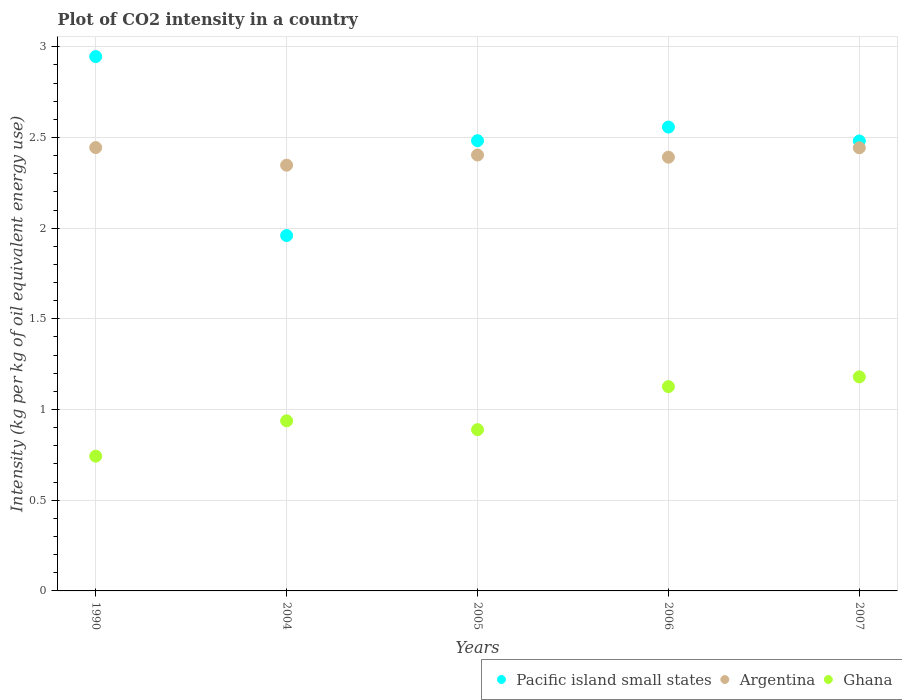How many different coloured dotlines are there?
Provide a short and direct response. 3. Is the number of dotlines equal to the number of legend labels?
Your response must be concise. Yes. What is the CO2 intensity in in Ghana in 2006?
Offer a very short reply. 1.13. Across all years, what is the maximum CO2 intensity in in Pacific island small states?
Provide a short and direct response. 2.95. Across all years, what is the minimum CO2 intensity in in Pacific island small states?
Give a very brief answer. 1.96. In which year was the CO2 intensity in in Ghana maximum?
Offer a very short reply. 2007. What is the total CO2 intensity in in Pacific island small states in the graph?
Ensure brevity in your answer.  12.43. What is the difference between the CO2 intensity in in Pacific island small states in 1990 and that in 2004?
Make the answer very short. 0.99. What is the difference between the CO2 intensity in in Ghana in 2006 and the CO2 intensity in in Pacific island small states in 2007?
Offer a very short reply. -1.35. What is the average CO2 intensity in in Ghana per year?
Make the answer very short. 0.98. In the year 2004, what is the difference between the CO2 intensity in in Pacific island small states and CO2 intensity in in Argentina?
Offer a very short reply. -0.39. In how many years, is the CO2 intensity in in Argentina greater than 1.3 kg?
Make the answer very short. 5. What is the ratio of the CO2 intensity in in Ghana in 1990 to that in 2005?
Make the answer very short. 0.84. What is the difference between the highest and the second highest CO2 intensity in in Argentina?
Keep it short and to the point. 0. What is the difference between the highest and the lowest CO2 intensity in in Argentina?
Keep it short and to the point. 0.1. In how many years, is the CO2 intensity in in Argentina greater than the average CO2 intensity in in Argentina taken over all years?
Keep it short and to the point. 2. Is the sum of the CO2 intensity in in Argentina in 1990 and 2004 greater than the maximum CO2 intensity in in Pacific island small states across all years?
Keep it short and to the point. Yes. Is the CO2 intensity in in Argentina strictly greater than the CO2 intensity in in Pacific island small states over the years?
Your response must be concise. No. Is the CO2 intensity in in Argentina strictly less than the CO2 intensity in in Pacific island small states over the years?
Offer a very short reply. No. How many years are there in the graph?
Offer a terse response. 5. What is the difference between two consecutive major ticks on the Y-axis?
Provide a short and direct response. 0.5. Does the graph contain any zero values?
Provide a succinct answer. No. Does the graph contain grids?
Offer a terse response. Yes. How are the legend labels stacked?
Provide a short and direct response. Horizontal. What is the title of the graph?
Provide a succinct answer. Plot of CO2 intensity in a country. Does "Mali" appear as one of the legend labels in the graph?
Your answer should be very brief. No. What is the label or title of the Y-axis?
Ensure brevity in your answer.  Intensity (kg per kg of oil equivalent energy use). What is the Intensity (kg per kg of oil equivalent energy use) in Pacific island small states in 1990?
Your response must be concise. 2.95. What is the Intensity (kg per kg of oil equivalent energy use) of Argentina in 1990?
Your response must be concise. 2.44. What is the Intensity (kg per kg of oil equivalent energy use) in Ghana in 1990?
Keep it short and to the point. 0.74. What is the Intensity (kg per kg of oil equivalent energy use) in Pacific island small states in 2004?
Offer a terse response. 1.96. What is the Intensity (kg per kg of oil equivalent energy use) in Argentina in 2004?
Make the answer very short. 2.35. What is the Intensity (kg per kg of oil equivalent energy use) in Ghana in 2004?
Offer a terse response. 0.94. What is the Intensity (kg per kg of oil equivalent energy use) in Pacific island small states in 2005?
Provide a short and direct response. 2.48. What is the Intensity (kg per kg of oil equivalent energy use) in Argentina in 2005?
Provide a short and direct response. 2.4. What is the Intensity (kg per kg of oil equivalent energy use) of Ghana in 2005?
Offer a very short reply. 0.89. What is the Intensity (kg per kg of oil equivalent energy use) of Pacific island small states in 2006?
Offer a terse response. 2.56. What is the Intensity (kg per kg of oil equivalent energy use) in Argentina in 2006?
Give a very brief answer. 2.39. What is the Intensity (kg per kg of oil equivalent energy use) in Ghana in 2006?
Your response must be concise. 1.13. What is the Intensity (kg per kg of oil equivalent energy use) of Pacific island small states in 2007?
Your answer should be very brief. 2.48. What is the Intensity (kg per kg of oil equivalent energy use) in Argentina in 2007?
Ensure brevity in your answer.  2.44. What is the Intensity (kg per kg of oil equivalent energy use) in Ghana in 2007?
Keep it short and to the point. 1.18. Across all years, what is the maximum Intensity (kg per kg of oil equivalent energy use) in Pacific island small states?
Give a very brief answer. 2.95. Across all years, what is the maximum Intensity (kg per kg of oil equivalent energy use) of Argentina?
Make the answer very short. 2.44. Across all years, what is the maximum Intensity (kg per kg of oil equivalent energy use) in Ghana?
Give a very brief answer. 1.18. Across all years, what is the minimum Intensity (kg per kg of oil equivalent energy use) of Pacific island small states?
Your answer should be compact. 1.96. Across all years, what is the minimum Intensity (kg per kg of oil equivalent energy use) of Argentina?
Ensure brevity in your answer.  2.35. Across all years, what is the minimum Intensity (kg per kg of oil equivalent energy use) of Ghana?
Your answer should be very brief. 0.74. What is the total Intensity (kg per kg of oil equivalent energy use) of Pacific island small states in the graph?
Your response must be concise. 12.43. What is the total Intensity (kg per kg of oil equivalent energy use) in Argentina in the graph?
Offer a very short reply. 12.03. What is the total Intensity (kg per kg of oil equivalent energy use) in Ghana in the graph?
Offer a very short reply. 4.88. What is the difference between the Intensity (kg per kg of oil equivalent energy use) of Pacific island small states in 1990 and that in 2004?
Offer a terse response. 0.99. What is the difference between the Intensity (kg per kg of oil equivalent energy use) in Argentina in 1990 and that in 2004?
Your answer should be very brief. 0.1. What is the difference between the Intensity (kg per kg of oil equivalent energy use) in Ghana in 1990 and that in 2004?
Ensure brevity in your answer.  -0.19. What is the difference between the Intensity (kg per kg of oil equivalent energy use) of Pacific island small states in 1990 and that in 2005?
Offer a very short reply. 0.46. What is the difference between the Intensity (kg per kg of oil equivalent energy use) of Argentina in 1990 and that in 2005?
Keep it short and to the point. 0.04. What is the difference between the Intensity (kg per kg of oil equivalent energy use) of Ghana in 1990 and that in 2005?
Your response must be concise. -0.15. What is the difference between the Intensity (kg per kg of oil equivalent energy use) of Pacific island small states in 1990 and that in 2006?
Offer a terse response. 0.39. What is the difference between the Intensity (kg per kg of oil equivalent energy use) in Argentina in 1990 and that in 2006?
Offer a very short reply. 0.05. What is the difference between the Intensity (kg per kg of oil equivalent energy use) of Ghana in 1990 and that in 2006?
Your answer should be very brief. -0.38. What is the difference between the Intensity (kg per kg of oil equivalent energy use) of Pacific island small states in 1990 and that in 2007?
Your response must be concise. 0.47. What is the difference between the Intensity (kg per kg of oil equivalent energy use) in Argentina in 1990 and that in 2007?
Provide a succinct answer. 0. What is the difference between the Intensity (kg per kg of oil equivalent energy use) in Ghana in 1990 and that in 2007?
Offer a very short reply. -0.44. What is the difference between the Intensity (kg per kg of oil equivalent energy use) in Pacific island small states in 2004 and that in 2005?
Make the answer very short. -0.52. What is the difference between the Intensity (kg per kg of oil equivalent energy use) of Argentina in 2004 and that in 2005?
Your response must be concise. -0.06. What is the difference between the Intensity (kg per kg of oil equivalent energy use) in Ghana in 2004 and that in 2005?
Offer a terse response. 0.05. What is the difference between the Intensity (kg per kg of oil equivalent energy use) of Pacific island small states in 2004 and that in 2006?
Your response must be concise. -0.6. What is the difference between the Intensity (kg per kg of oil equivalent energy use) of Argentina in 2004 and that in 2006?
Offer a terse response. -0.04. What is the difference between the Intensity (kg per kg of oil equivalent energy use) of Ghana in 2004 and that in 2006?
Keep it short and to the point. -0.19. What is the difference between the Intensity (kg per kg of oil equivalent energy use) in Pacific island small states in 2004 and that in 2007?
Make the answer very short. -0.52. What is the difference between the Intensity (kg per kg of oil equivalent energy use) in Argentina in 2004 and that in 2007?
Give a very brief answer. -0.1. What is the difference between the Intensity (kg per kg of oil equivalent energy use) in Ghana in 2004 and that in 2007?
Your response must be concise. -0.24. What is the difference between the Intensity (kg per kg of oil equivalent energy use) in Pacific island small states in 2005 and that in 2006?
Offer a very short reply. -0.08. What is the difference between the Intensity (kg per kg of oil equivalent energy use) in Argentina in 2005 and that in 2006?
Provide a succinct answer. 0.01. What is the difference between the Intensity (kg per kg of oil equivalent energy use) in Ghana in 2005 and that in 2006?
Provide a succinct answer. -0.24. What is the difference between the Intensity (kg per kg of oil equivalent energy use) of Pacific island small states in 2005 and that in 2007?
Your answer should be compact. 0. What is the difference between the Intensity (kg per kg of oil equivalent energy use) in Argentina in 2005 and that in 2007?
Offer a terse response. -0.04. What is the difference between the Intensity (kg per kg of oil equivalent energy use) in Ghana in 2005 and that in 2007?
Keep it short and to the point. -0.29. What is the difference between the Intensity (kg per kg of oil equivalent energy use) in Pacific island small states in 2006 and that in 2007?
Your answer should be very brief. 0.08. What is the difference between the Intensity (kg per kg of oil equivalent energy use) in Argentina in 2006 and that in 2007?
Your answer should be very brief. -0.05. What is the difference between the Intensity (kg per kg of oil equivalent energy use) in Ghana in 2006 and that in 2007?
Ensure brevity in your answer.  -0.05. What is the difference between the Intensity (kg per kg of oil equivalent energy use) in Pacific island small states in 1990 and the Intensity (kg per kg of oil equivalent energy use) in Argentina in 2004?
Provide a short and direct response. 0.6. What is the difference between the Intensity (kg per kg of oil equivalent energy use) in Pacific island small states in 1990 and the Intensity (kg per kg of oil equivalent energy use) in Ghana in 2004?
Your response must be concise. 2.01. What is the difference between the Intensity (kg per kg of oil equivalent energy use) of Argentina in 1990 and the Intensity (kg per kg of oil equivalent energy use) of Ghana in 2004?
Give a very brief answer. 1.51. What is the difference between the Intensity (kg per kg of oil equivalent energy use) in Pacific island small states in 1990 and the Intensity (kg per kg of oil equivalent energy use) in Argentina in 2005?
Give a very brief answer. 0.54. What is the difference between the Intensity (kg per kg of oil equivalent energy use) of Pacific island small states in 1990 and the Intensity (kg per kg of oil equivalent energy use) of Ghana in 2005?
Offer a terse response. 2.06. What is the difference between the Intensity (kg per kg of oil equivalent energy use) of Argentina in 1990 and the Intensity (kg per kg of oil equivalent energy use) of Ghana in 2005?
Your answer should be compact. 1.56. What is the difference between the Intensity (kg per kg of oil equivalent energy use) of Pacific island small states in 1990 and the Intensity (kg per kg of oil equivalent energy use) of Argentina in 2006?
Offer a very short reply. 0.55. What is the difference between the Intensity (kg per kg of oil equivalent energy use) of Pacific island small states in 1990 and the Intensity (kg per kg of oil equivalent energy use) of Ghana in 2006?
Keep it short and to the point. 1.82. What is the difference between the Intensity (kg per kg of oil equivalent energy use) in Argentina in 1990 and the Intensity (kg per kg of oil equivalent energy use) in Ghana in 2006?
Ensure brevity in your answer.  1.32. What is the difference between the Intensity (kg per kg of oil equivalent energy use) in Pacific island small states in 1990 and the Intensity (kg per kg of oil equivalent energy use) in Argentina in 2007?
Offer a terse response. 0.5. What is the difference between the Intensity (kg per kg of oil equivalent energy use) in Pacific island small states in 1990 and the Intensity (kg per kg of oil equivalent energy use) in Ghana in 2007?
Offer a terse response. 1.77. What is the difference between the Intensity (kg per kg of oil equivalent energy use) of Argentina in 1990 and the Intensity (kg per kg of oil equivalent energy use) of Ghana in 2007?
Offer a very short reply. 1.26. What is the difference between the Intensity (kg per kg of oil equivalent energy use) of Pacific island small states in 2004 and the Intensity (kg per kg of oil equivalent energy use) of Argentina in 2005?
Your response must be concise. -0.44. What is the difference between the Intensity (kg per kg of oil equivalent energy use) of Pacific island small states in 2004 and the Intensity (kg per kg of oil equivalent energy use) of Ghana in 2005?
Your answer should be very brief. 1.07. What is the difference between the Intensity (kg per kg of oil equivalent energy use) of Argentina in 2004 and the Intensity (kg per kg of oil equivalent energy use) of Ghana in 2005?
Your response must be concise. 1.46. What is the difference between the Intensity (kg per kg of oil equivalent energy use) in Pacific island small states in 2004 and the Intensity (kg per kg of oil equivalent energy use) in Argentina in 2006?
Keep it short and to the point. -0.43. What is the difference between the Intensity (kg per kg of oil equivalent energy use) of Pacific island small states in 2004 and the Intensity (kg per kg of oil equivalent energy use) of Ghana in 2006?
Your answer should be very brief. 0.83. What is the difference between the Intensity (kg per kg of oil equivalent energy use) in Argentina in 2004 and the Intensity (kg per kg of oil equivalent energy use) in Ghana in 2006?
Offer a very short reply. 1.22. What is the difference between the Intensity (kg per kg of oil equivalent energy use) in Pacific island small states in 2004 and the Intensity (kg per kg of oil equivalent energy use) in Argentina in 2007?
Keep it short and to the point. -0.48. What is the difference between the Intensity (kg per kg of oil equivalent energy use) of Pacific island small states in 2004 and the Intensity (kg per kg of oil equivalent energy use) of Ghana in 2007?
Give a very brief answer. 0.78. What is the difference between the Intensity (kg per kg of oil equivalent energy use) in Argentina in 2004 and the Intensity (kg per kg of oil equivalent energy use) in Ghana in 2007?
Offer a terse response. 1.17. What is the difference between the Intensity (kg per kg of oil equivalent energy use) in Pacific island small states in 2005 and the Intensity (kg per kg of oil equivalent energy use) in Argentina in 2006?
Keep it short and to the point. 0.09. What is the difference between the Intensity (kg per kg of oil equivalent energy use) of Pacific island small states in 2005 and the Intensity (kg per kg of oil equivalent energy use) of Ghana in 2006?
Keep it short and to the point. 1.36. What is the difference between the Intensity (kg per kg of oil equivalent energy use) in Argentina in 2005 and the Intensity (kg per kg of oil equivalent energy use) in Ghana in 2006?
Offer a very short reply. 1.28. What is the difference between the Intensity (kg per kg of oil equivalent energy use) of Pacific island small states in 2005 and the Intensity (kg per kg of oil equivalent energy use) of Argentina in 2007?
Make the answer very short. 0.04. What is the difference between the Intensity (kg per kg of oil equivalent energy use) in Pacific island small states in 2005 and the Intensity (kg per kg of oil equivalent energy use) in Ghana in 2007?
Make the answer very short. 1.3. What is the difference between the Intensity (kg per kg of oil equivalent energy use) in Argentina in 2005 and the Intensity (kg per kg of oil equivalent energy use) in Ghana in 2007?
Give a very brief answer. 1.22. What is the difference between the Intensity (kg per kg of oil equivalent energy use) in Pacific island small states in 2006 and the Intensity (kg per kg of oil equivalent energy use) in Argentina in 2007?
Provide a short and direct response. 0.11. What is the difference between the Intensity (kg per kg of oil equivalent energy use) of Pacific island small states in 2006 and the Intensity (kg per kg of oil equivalent energy use) of Ghana in 2007?
Keep it short and to the point. 1.38. What is the difference between the Intensity (kg per kg of oil equivalent energy use) of Argentina in 2006 and the Intensity (kg per kg of oil equivalent energy use) of Ghana in 2007?
Ensure brevity in your answer.  1.21. What is the average Intensity (kg per kg of oil equivalent energy use) in Pacific island small states per year?
Your response must be concise. 2.48. What is the average Intensity (kg per kg of oil equivalent energy use) of Argentina per year?
Provide a short and direct response. 2.41. What is the average Intensity (kg per kg of oil equivalent energy use) of Ghana per year?
Offer a terse response. 0.98. In the year 1990, what is the difference between the Intensity (kg per kg of oil equivalent energy use) of Pacific island small states and Intensity (kg per kg of oil equivalent energy use) of Argentina?
Offer a very short reply. 0.5. In the year 1990, what is the difference between the Intensity (kg per kg of oil equivalent energy use) of Pacific island small states and Intensity (kg per kg of oil equivalent energy use) of Ghana?
Your response must be concise. 2.2. In the year 1990, what is the difference between the Intensity (kg per kg of oil equivalent energy use) in Argentina and Intensity (kg per kg of oil equivalent energy use) in Ghana?
Your answer should be very brief. 1.7. In the year 2004, what is the difference between the Intensity (kg per kg of oil equivalent energy use) of Pacific island small states and Intensity (kg per kg of oil equivalent energy use) of Argentina?
Provide a succinct answer. -0.39. In the year 2004, what is the difference between the Intensity (kg per kg of oil equivalent energy use) in Pacific island small states and Intensity (kg per kg of oil equivalent energy use) in Ghana?
Make the answer very short. 1.02. In the year 2004, what is the difference between the Intensity (kg per kg of oil equivalent energy use) of Argentina and Intensity (kg per kg of oil equivalent energy use) of Ghana?
Keep it short and to the point. 1.41. In the year 2005, what is the difference between the Intensity (kg per kg of oil equivalent energy use) in Pacific island small states and Intensity (kg per kg of oil equivalent energy use) in Argentina?
Ensure brevity in your answer.  0.08. In the year 2005, what is the difference between the Intensity (kg per kg of oil equivalent energy use) in Pacific island small states and Intensity (kg per kg of oil equivalent energy use) in Ghana?
Offer a very short reply. 1.59. In the year 2005, what is the difference between the Intensity (kg per kg of oil equivalent energy use) in Argentina and Intensity (kg per kg of oil equivalent energy use) in Ghana?
Make the answer very short. 1.51. In the year 2006, what is the difference between the Intensity (kg per kg of oil equivalent energy use) in Pacific island small states and Intensity (kg per kg of oil equivalent energy use) in Argentina?
Offer a terse response. 0.17. In the year 2006, what is the difference between the Intensity (kg per kg of oil equivalent energy use) in Pacific island small states and Intensity (kg per kg of oil equivalent energy use) in Ghana?
Make the answer very short. 1.43. In the year 2006, what is the difference between the Intensity (kg per kg of oil equivalent energy use) in Argentina and Intensity (kg per kg of oil equivalent energy use) in Ghana?
Keep it short and to the point. 1.26. In the year 2007, what is the difference between the Intensity (kg per kg of oil equivalent energy use) of Pacific island small states and Intensity (kg per kg of oil equivalent energy use) of Argentina?
Make the answer very short. 0.04. In the year 2007, what is the difference between the Intensity (kg per kg of oil equivalent energy use) in Pacific island small states and Intensity (kg per kg of oil equivalent energy use) in Ghana?
Offer a very short reply. 1.3. In the year 2007, what is the difference between the Intensity (kg per kg of oil equivalent energy use) in Argentina and Intensity (kg per kg of oil equivalent energy use) in Ghana?
Ensure brevity in your answer.  1.26. What is the ratio of the Intensity (kg per kg of oil equivalent energy use) of Pacific island small states in 1990 to that in 2004?
Provide a succinct answer. 1.5. What is the ratio of the Intensity (kg per kg of oil equivalent energy use) of Argentina in 1990 to that in 2004?
Provide a succinct answer. 1.04. What is the ratio of the Intensity (kg per kg of oil equivalent energy use) of Ghana in 1990 to that in 2004?
Offer a very short reply. 0.79. What is the ratio of the Intensity (kg per kg of oil equivalent energy use) in Pacific island small states in 1990 to that in 2005?
Offer a very short reply. 1.19. What is the ratio of the Intensity (kg per kg of oil equivalent energy use) of Ghana in 1990 to that in 2005?
Offer a very short reply. 0.84. What is the ratio of the Intensity (kg per kg of oil equivalent energy use) in Pacific island small states in 1990 to that in 2006?
Your answer should be compact. 1.15. What is the ratio of the Intensity (kg per kg of oil equivalent energy use) of Argentina in 1990 to that in 2006?
Your response must be concise. 1.02. What is the ratio of the Intensity (kg per kg of oil equivalent energy use) in Ghana in 1990 to that in 2006?
Offer a terse response. 0.66. What is the ratio of the Intensity (kg per kg of oil equivalent energy use) in Pacific island small states in 1990 to that in 2007?
Keep it short and to the point. 1.19. What is the ratio of the Intensity (kg per kg of oil equivalent energy use) of Argentina in 1990 to that in 2007?
Make the answer very short. 1. What is the ratio of the Intensity (kg per kg of oil equivalent energy use) of Ghana in 1990 to that in 2007?
Ensure brevity in your answer.  0.63. What is the ratio of the Intensity (kg per kg of oil equivalent energy use) of Pacific island small states in 2004 to that in 2005?
Your answer should be very brief. 0.79. What is the ratio of the Intensity (kg per kg of oil equivalent energy use) in Argentina in 2004 to that in 2005?
Provide a short and direct response. 0.98. What is the ratio of the Intensity (kg per kg of oil equivalent energy use) of Ghana in 2004 to that in 2005?
Give a very brief answer. 1.05. What is the ratio of the Intensity (kg per kg of oil equivalent energy use) in Pacific island small states in 2004 to that in 2006?
Offer a terse response. 0.77. What is the ratio of the Intensity (kg per kg of oil equivalent energy use) of Argentina in 2004 to that in 2006?
Your answer should be compact. 0.98. What is the ratio of the Intensity (kg per kg of oil equivalent energy use) of Ghana in 2004 to that in 2006?
Your answer should be compact. 0.83. What is the ratio of the Intensity (kg per kg of oil equivalent energy use) of Pacific island small states in 2004 to that in 2007?
Your answer should be very brief. 0.79. What is the ratio of the Intensity (kg per kg of oil equivalent energy use) of Argentina in 2004 to that in 2007?
Ensure brevity in your answer.  0.96. What is the ratio of the Intensity (kg per kg of oil equivalent energy use) in Ghana in 2004 to that in 2007?
Your answer should be very brief. 0.79. What is the ratio of the Intensity (kg per kg of oil equivalent energy use) of Pacific island small states in 2005 to that in 2006?
Your answer should be very brief. 0.97. What is the ratio of the Intensity (kg per kg of oil equivalent energy use) in Argentina in 2005 to that in 2006?
Offer a very short reply. 1. What is the ratio of the Intensity (kg per kg of oil equivalent energy use) of Ghana in 2005 to that in 2006?
Make the answer very short. 0.79. What is the ratio of the Intensity (kg per kg of oil equivalent energy use) of Pacific island small states in 2005 to that in 2007?
Your answer should be very brief. 1. What is the ratio of the Intensity (kg per kg of oil equivalent energy use) of Argentina in 2005 to that in 2007?
Your response must be concise. 0.98. What is the ratio of the Intensity (kg per kg of oil equivalent energy use) in Ghana in 2005 to that in 2007?
Keep it short and to the point. 0.75. What is the ratio of the Intensity (kg per kg of oil equivalent energy use) in Pacific island small states in 2006 to that in 2007?
Keep it short and to the point. 1.03. What is the ratio of the Intensity (kg per kg of oil equivalent energy use) of Argentina in 2006 to that in 2007?
Offer a very short reply. 0.98. What is the ratio of the Intensity (kg per kg of oil equivalent energy use) of Ghana in 2006 to that in 2007?
Your answer should be very brief. 0.95. What is the difference between the highest and the second highest Intensity (kg per kg of oil equivalent energy use) of Pacific island small states?
Ensure brevity in your answer.  0.39. What is the difference between the highest and the second highest Intensity (kg per kg of oil equivalent energy use) in Argentina?
Your answer should be compact. 0. What is the difference between the highest and the second highest Intensity (kg per kg of oil equivalent energy use) in Ghana?
Your answer should be very brief. 0.05. What is the difference between the highest and the lowest Intensity (kg per kg of oil equivalent energy use) of Pacific island small states?
Ensure brevity in your answer.  0.99. What is the difference between the highest and the lowest Intensity (kg per kg of oil equivalent energy use) of Argentina?
Make the answer very short. 0.1. What is the difference between the highest and the lowest Intensity (kg per kg of oil equivalent energy use) in Ghana?
Provide a short and direct response. 0.44. 